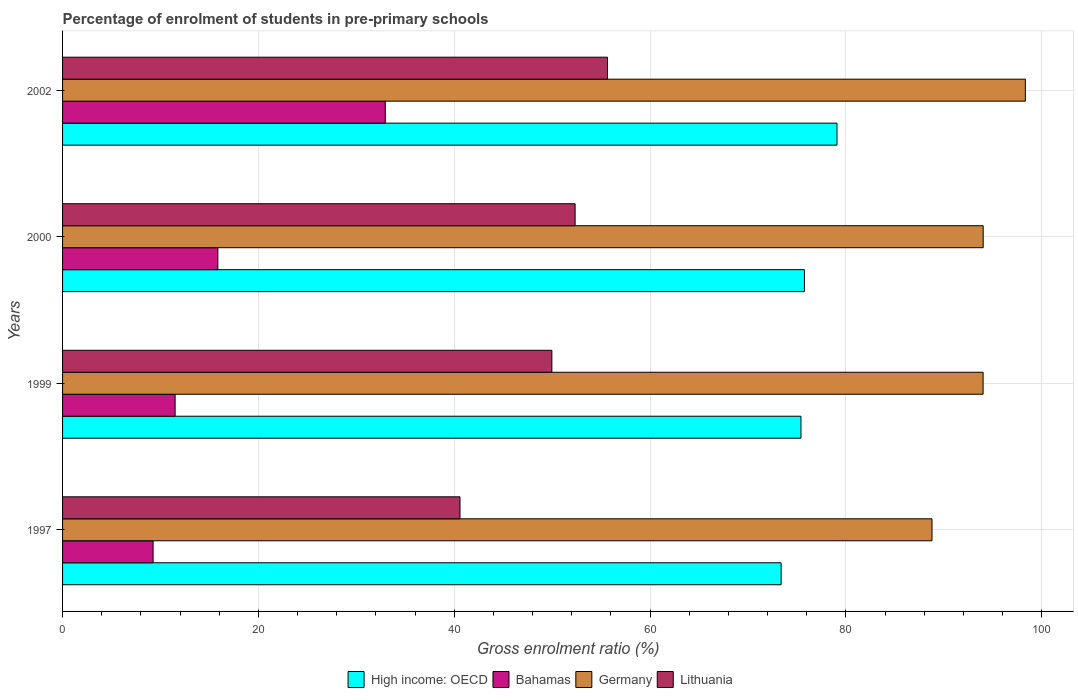Are the number of bars on each tick of the Y-axis equal?
Provide a short and direct response. Yes. How many bars are there on the 3rd tick from the bottom?
Your answer should be compact. 4. What is the percentage of students enrolled in pre-primary schools in Germany in 2000?
Your answer should be compact. 94.01. Across all years, what is the maximum percentage of students enrolled in pre-primary schools in Lithuania?
Offer a terse response. 55.65. Across all years, what is the minimum percentage of students enrolled in pre-primary schools in Lithuania?
Ensure brevity in your answer.  40.58. In which year was the percentage of students enrolled in pre-primary schools in Germany maximum?
Provide a succinct answer. 2002. What is the total percentage of students enrolled in pre-primary schools in High income: OECD in the graph?
Give a very brief answer. 303.62. What is the difference between the percentage of students enrolled in pre-primary schools in Bahamas in 1999 and that in 2002?
Make the answer very short. -21.46. What is the difference between the percentage of students enrolled in pre-primary schools in High income: OECD in 1997 and the percentage of students enrolled in pre-primary schools in Lithuania in 2002?
Your answer should be very brief. 17.73. What is the average percentage of students enrolled in pre-primary schools in Bahamas per year?
Ensure brevity in your answer.  17.39. In the year 1997, what is the difference between the percentage of students enrolled in pre-primary schools in Germany and percentage of students enrolled in pre-primary schools in Bahamas?
Your answer should be very brief. 79.54. In how many years, is the percentage of students enrolled in pre-primary schools in High income: OECD greater than 12 %?
Provide a short and direct response. 4. What is the ratio of the percentage of students enrolled in pre-primary schools in Bahamas in 1997 to that in 1999?
Keep it short and to the point. 0.8. Is the difference between the percentage of students enrolled in pre-primary schools in Germany in 1997 and 2000 greater than the difference between the percentage of students enrolled in pre-primary schools in Bahamas in 1997 and 2000?
Provide a succinct answer. Yes. What is the difference between the highest and the second highest percentage of students enrolled in pre-primary schools in Germany?
Your response must be concise. 4.31. What is the difference between the highest and the lowest percentage of students enrolled in pre-primary schools in Bahamas?
Ensure brevity in your answer.  23.71. In how many years, is the percentage of students enrolled in pre-primary schools in High income: OECD greater than the average percentage of students enrolled in pre-primary schools in High income: OECD taken over all years?
Offer a terse response. 1. Is the sum of the percentage of students enrolled in pre-primary schools in Bahamas in 1999 and 2000 greater than the maximum percentage of students enrolled in pre-primary schools in Lithuania across all years?
Your response must be concise. No. What does the 3rd bar from the top in 1997 represents?
Your answer should be very brief. Bahamas. What does the 1st bar from the bottom in 1999 represents?
Your answer should be compact. High income: OECD. Is it the case that in every year, the sum of the percentage of students enrolled in pre-primary schools in Germany and percentage of students enrolled in pre-primary schools in High income: OECD is greater than the percentage of students enrolled in pre-primary schools in Bahamas?
Offer a terse response. Yes. What is the difference between two consecutive major ticks on the X-axis?
Provide a short and direct response. 20. Are the values on the major ticks of X-axis written in scientific E-notation?
Provide a short and direct response. No. Does the graph contain grids?
Offer a terse response. Yes. Where does the legend appear in the graph?
Offer a terse response. Bottom center. How many legend labels are there?
Ensure brevity in your answer.  4. What is the title of the graph?
Provide a succinct answer. Percentage of enrolment of students in pre-primary schools. What is the label or title of the X-axis?
Ensure brevity in your answer.  Gross enrolment ratio (%). What is the label or title of the Y-axis?
Give a very brief answer. Years. What is the Gross enrolment ratio (%) of High income: OECD in 1997?
Offer a terse response. 73.38. What is the Gross enrolment ratio (%) in Bahamas in 1997?
Keep it short and to the point. 9.25. What is the Gross enrolment ratio (%) of Germany in 1997?
Give a very brief answer. 88.79. What is the Gross enrolment ratio (%) of Lithuania in 1997?
Make the answer very short. 40.58. What is the Gross enrolment ratio (%) of High income: OECD in 1999?
Offer a very short reply. 75.4. What is the Gross enrolment ratio (%) of Bahamas in 1999?
Make the answer very short. 11.49. What is the Gross enrolment ratio (%) in Germany in 1999?
Offer a terse response. 94. What is the Gross enrolment ratio (%) of Lithuania in 1999?
Your answer should be very brief. 49.97. What is the Gross enrolment ratio (%) of High income: OECD in 2000?
Offer a terse response. 75.76. What is the Gross enrolment ratio (%) in Bahamas in 2000?
Provide a succinct answer. 15.86. What is the Gross enrolment ratio (%) of Germany in 2000?
Your response must be concise. 94.01. What is the Gross enrolment ratio (%) in Lithuania in 2000?
Provide a succinct answer. 52.34. What is the Gross enrolment ratio (%) in High income: OECD in 2002?
Your answer should be very brief. 79.08. What is the Gross enrolment ratio (%) in Bahamas in 2002?
Give a very brief answer. 32.96. What is the Gross enrolment ratio (%) of Germany in 2002?
Offer a terse response. 98.32. What is the Gross enrolment ratio (%) in Lithuania in 2002?
Your answer should be compact. 55.65. Across all years, what is the maximum Gross enrolment ratio (%) in High income: OECD?
Ensure brevity in your answer.  79.08. Across all years, what is the maximum Gross enrolment ratio (%) of Bahamas?
Make the answer very short. 32.96. Across all years, what is the maximum Gross enrolment ratio (%) in Germany?
Keep it short and to the point. 98.32. Across all years, what is the maximum Gross enrolment ratio (%) of Lithuania?
Give a very brief answer. 55.65. Across all years, what is the minimum Gross enrolment ratio (%) of High income: OECD?
Provide a short and direct response. 73.38. Across all years, what is the minimum Gross enrolment ratio (%) of Bahamas?
Your response must be concise. 9.25. Across all years, what is the minimum Gross enrolment ratio (%) in Germany?
Give a very brief answer. 88.79. Across all years, what is the minimum Gross enrolment ratio (%) in Lithuania?
Provide a short and direct response. 40.58. What is the total Gross enrolment ratio (%) of High income: OECD in the graph?
Offer a very short reply. 303.62. What is the total Gross enrolment ratio (%) in Bahamas in the graph?
Keep it short and to the point. 69.55. What is the total Gross enrolment ratio (%) of Germany in the graph?
Make the answer very short. 375.12. What is the total Gross enrolment ratio (%) of Lithuania in the graph?
Offer a very short reply. 198.54. What is the difference between the Gross enrolment ratio (%) in High income: OECD in 1997 and that in 1999?
Ensure brevity in your answer.  -2.03. What is the difference between the Gross enrolment ratio (%) in Bahamas in 1997 and that in 1999?
Your answer should be very brief. -2.25. What is the difference between the Gross enrolment ratio (%) in Germany in 1997 and that in 1999?
Ensure brevity in your answer.  -5.22. What is the difference between the Gross enrolment ratio (%) of Lithuania in 1997 and that in 1999?
Your answer should be compact. -9.38. What is the difference between the Gross enrolment ratio (%) of High income: OECD in 1997 and that in 2000?
Provide a succinct answer. -2.38. What is the difference between the Gross enrolment ratio (%) of Bahamas in 1997 and that in 2000?
Provide a succinct answer. -6.61. What is the difference between the Gross enrolment ratio (%) of Germany in 1997 and that in 2000?
Make the answer very short. -5.23. What is the difference between the Gross enrolment ratio (%) in Lithuania in 1997 and that in 2000?
Offer a very short reply. -11.76. What is the difference between the Gross enrolment ratio (%) of High income: OECD in 1997 and that in 2002?
Make the answer very short. -5.71. What is the difference between the Gross enrolment ratio (%) of Bahamas in 1997 and that in 2002?
Your answer should be very brief. -23.71. What is the difference between the Gross enrolment ratio (%) in Germany in 1997 and that in 2002?
Offer a terse response. -9.53. What is the difference between the Gross enrolment ratio (%) in Lithuania in 1997 and that in 2002?
Your answer should be compact. -15.06. What is the difference between the Gross enrolment ratio (%) of High income: OECD in 1999 and that in 2000?
Provide a short and direct response. -0.35. What is the difference between the Gross enrolment ratio (%) in Bahamas in 1999 and that in 2000?
Offer a terse response. -4.37. What is the difference between the Gross enrolment ratio (%) in Germany in 1999 and that in 2000?
Your response must be concise. -0.01. What is the difference between the Gross enrolment ratio (%) of Lithuania in 1999 and that in 2000?
Your response must be concise. -2.37. What is the difference between the Gross enrolment ratio (%) of High income: OECD in 1999 and that in 2002?
Keep it short and to the point. -3.68. What is the difference between the Gross enrolment ratio (%) in Bahamas in 1999 and that in 2002?
Your answer should be very brief. -21.46. What is the difference between the Gross enrolment ratio (%) of Germany in 1999 and that in 2002?
Provide a succinct answer. -4.32. What is the difference between the Gross enrolment ratio (%) of Lithuania in 1999 and that in 2002?
Offer a terse response. -5.68. What is the difference between the Gross enrolment ratio (%) of High income: OECD in 2000 and that in 2002?
Your answer should be compact. -3.33. What is the difference between the Gross enrolment ratio (%) in Bahamas in 2000 and that in 2002?
Keep it short and to the point. -17.1. What is the difference between the Gross enrolment ratio (%) in Germany in 2000 and that in 2002?
Your answer should be very brief. -4.31. What is the difference between the Gross enrolment ratio (%) of Lithuania in 2000 and that in 2002?
Give a very brief answer. -3.31. What is the difference between the Gross enrolment ratio (%) of High income: OECD in 1997 and the Gross enrolment ratio (%) of Bahamas in 1999?
Offer a very short reply. 61.88. What is the difference between the Gross enrolment ratio (%) in High income: OECD in 1997 and the Gross enrolment ratio (%) in Germany in 1999?
Give a very brief answer. -20.63. What is the difference between the Gross enrolment ratio (%) of High income: OECD in 1997 and the Gross enrolment ratio (%) of Lithuania in 1999?
Make the answer very short. 23.41. What is the difference between the Gross enrolment ratio (%) in Bahamas in 1997 and the Gross enrolment ratio (%) in Germany in 1999?
Provide a short and direct response. -84.76. What is the difference between the Gross enrolment ratio (%) in Bahamas in 1997 and the Gross enrolment ratio (%) in Lithuania in 1999?
Offer a very short reply. -40.72. What is the difference between the Gross enrolment ratio (%) in Germany in 1997 and the Gross enrolment ratio (%) in Lithuania in 1999?
Keep it short and to the point. 38.82. What is the difference between the Gross enrolment ratio (%) in High income: OECD in 1997 and the Gross enrolment ratio (%) in Bahamas in 2000?
Your answer should be very brief. 57.52. What is the difference between the Gross enrolment ratio (%) in High income: OECD in 1997 and the Gross enrolment ratio (%) in Germany in 2000?
Ensure brevity in your answer.  -20.64. What is the difference between the Gross enrolment ratio (%) of High income: OECD in 1997 and the Gross enrolment ratio (%) of Lithuania in 2000?
Provide a short and direct response. 21.04. What is the difference between the Gross enrolment ratio (%) of Bahamas in 1997 and the Gross enrolment ratio (%) of Germany in 2000?
Make the answer very short. -84.77. What is the difference between the Gross enrolment ratio (%) of Bahamas in 1997 and the Gross enrolment ratio (%) of Lithuania in 2000?
Provide a short and direct response. -43.1. What is the difference between the Gross enrolment ratio (%) of Germany in 1997 and the Gross enrolment ratio (%) of Lithuania in 2000?
Your response must be concise. 36.45. What is the difference between the Gross enrolment ratio (%) in High income: OECD in 1997 and the Gross enrolment ratio (%) in Bahamas in 2002?
Make the answer very short. 40.42. What is the difference between the Gross enrolment ratio (%) in High income: OECD in 1997 and the Gross enrolment ratio (%) in Germany in 2002?
Offer a terse response. -24.94. What is the difference between the Gross enrolment ratio (%) of High income: OECD in 1997 and the Gross enrolment ratio (%) of Lithuania in 2002?
Offer a very short reply. 17.73. What is the difference between the Gross enrolment ratio (%) in Bahamas in 1997 and the Gross enrolment ratio (%) in Germany in 2002?
Ensure brevity in your answer.  -89.07. What is the difference between the Gross enrolment ratio (%) of Bahamas in 1997 and the Gross enrolment ratio (%) of Lithuania in 2002?
Your answer should be compact. -46.4. What is the difference between the Gross enrolment ratio (%) of Germany in 1997 and the Gross enrolment ratio (%) of Lithuania in 2002?
Give a very brief answer. 33.14. What is the difference between the Gross enrolment ratio (%) of High income: OECD in 1999 and the Gross enrolment ratio (%) of Bahamas in 2000?
Offer a very short reply. 59.54. What is the difference between the Gross enrolment ratio (%) in High income: OECD in 1999 and the Gross enrolment ratio (%) in Germany in 2000?
Keep it short and to the point. -18.61. What is the difference between the Gross enrolment ratio (%) in High income: OECD in 1999 and the Gross enrolment ratio (%) in Lithuania in 2000?
Your answer should be compact. 23.06. What is the difference between the Gross enrolment ratio (%) in Bahamas in 1999 and the Gross enrolment ratio (%) in Germany in 2000?
Keep it short and to the point. -82.52. What is the difference between the Gross enrolment ratio (%) in Bahamas in 1999 and the Gross enrolment ratio (%) in Lithuania in 2000?
Offer a very short reply. -40.85. What is the difference between the Gross enrolment ratio (%) of Germany in 1999 and the Gross enrolment ratio (%) of Lithuania in 2000?
Provide a short and direct response. 41.66. What is the difference between the Gross enrolment ratio (%) in High income: OECD in 1999 and the Gross enrolment ratio (%) in Bahamas in 2002?
Offer a very short reply. 42.45. What is the difference between the Gross enrolment ratio (%) of High income: OECD in 1999 and the Gross enrolment ratio (%) of Germany in 2002?
Your answer should be compact. -22.91. What is the difference between the Gross enrolment ratio (%) of High income: OECD in 1999 and the Gross enrolment ratio (%) of Lithuania in 2002?
Ensure brevity in your answer.  19.76. What is the difference between the Gross enrolment ratio (%) in Bahamas in 1999 and the Gross enrolment ratio (%) in Germany in 2002?
Keep it short and to the point. -86.83. What is the difference between the Gross enrolment ratio (%) of Bahamas in 1999 and the Gross enrolment ratio (%) of Lithuania in 2002?
Your response must be concise. -44.15. What is the difference between the Gross enrolment ratio (%) in Germany in 1999 and the Gross enrolment ratio (%) in Lithuania in 2002?
Ensure brevity in your answer.  38.36. What is the difference between the Gross enrolment ratio (%) of High income: OECD in 2000 and the Gross enrolment ratio (%) of Bahamas in 2002?
Your answer should be very brief. 42.8. What is the difference between the Gross enrolment ratio (%) in High income: OECD in 2000 and the Gross enrolment ratio (%) in Germany in 2002?
Offer a terse response. -22.56. What is the difference between the Gross enrolment ratio (%) of High income: OECD in 2000 and the Gross enrolment ratio (%) of Lithuania in 2002?
Your answer should be very brief. 20.11. What is the difference between the Gross enrolment ratio (%) of Bahamas in 2000 and the Gross enrolment ratio (%) of Germany in 2002?
Make the answer very short. -82.46. What is the difference between the Gross enrolment ratio (%) of Bahamas in 2000 and the Gross enrolment ratio (%) of Lithuania in 2002?
Provide a succinct answer. -39.79. What is the difference between the Gross enrolment ratio (%) of Germany in 2000 and the Gross enrolment ratio (%) of Lithuania in 2002?
Offer a very short reply. 38.37. What is the average Gross enrolment ratio (%) in High income: OECD per year?
Provide a succinct answer. 75.91. What is the average Gross enrolment ratio (%) of Bahamas per year?
Provide a succinct answer. 17.39. What is the average Gross enrolment ratio (%) of Germany per year?
Provide a short and direct response. 93.78. What is the average Gross enrolment ratio (%) of Lithuania per year?
Your answer should be very brief. 49.63. In the year 1997, what is the difference between the Gross enrolment ratio (%) of High income: OECD and Gross enrolment ratio (%) of Bahamas?
Ensure brevity in your answer.  64.13. In the year 1997, what is the difference between the Gross enrolment ratio (%) in High income: OECD and Gross enrolment ratio (%) in Germany?
Provide a succinct answer. -15.41. In the year 1997, what is the difference between the Gross enrolment ratio (%) in High income: OECD and Gross enrolment ratio (%) in Lithuania?
Offer a terse response. 32.79. In the year 1997, what is the difference between the Gross enrolment ratio (%) of Bahamas and Gross enrolment ratio (%) of Germany?
Offer a very short reply. -79.54. In the year 1997, what is the difference between the Gross enrolment ratio (%) of Bahamas and Gross enrolment ratio (%) of Lithuania?
Give a very brief answer. -31.34. In the year 1997, what is the difference between the Gross enrolment ratio (%) of Germany and Gross enrolment ratio (%) of Lithuania?
Your answer should be compact. 48.2. In the year 1999, what is the difference between the Gross enrolment ratio (%) in High income: OECD and Gross enrolment ratio (%) in Bahamas?
Your response must be concise. 63.91. In the year 1999, what is the difference between the Gross enrolment ratio (%) of High income: OECD and Gross enrolment ratio (%) of Germany?
Provide a succinct answer. -18.6. In the year 1999, what is the difference between the Gross enrolment ratio (%) in High income: OECD and Gross enrolment ratio (%) in Lithuania?
Keep it short and to the point. 25.44. In the year 1999, what is the difference between the Gross enrolment ratio (%) of Bahamas and Gross enrolment ratio (%) of Germany?
Your response must be concise. -82.51. In the year 1999, what is the difference between the Gross enrolment ratio (%) in Bahamas and Gross enrolment ratio (%) in Lithuania?
Provide a short and direct response. -38.47. In the year 1999, what is the difference between the Gross enrolment ratio (%) of Germany and Gross enrolment ratio (%) of Lithuania?
Offer a very short reply. 44.04. In the year 2000, what is the difference between the Gross enrolment ratio (%) in High income: OECD and Gross enrolment ratio (%) in Bahamas?
Give a very brief answer. 59.9. In the year 2000, what is the difference between the Gross enrolment ratio (%) of High income: OECD and Gross enrolment ratio (%) of Germany?
Keep it short and to the point. -18.25. In the year 2000, what is the difference between the Gross enrolment ratio (%) in High income: OECD and Gross enrolment ratio (%) in Lithuania?
Make the answer very short. 23.42. In the year 2000, what is the difference between the Gross enrolment ratio (%) of Bahamas and Gross enrolment ratio (%) of Germany?
Make the answer very short. -78.15. In the year 2000, what is the difference between the Gross enrolment ratio (%) of Bahamas and Gross enrolment ratio (%) of Lithuania?
Give a very brief answer. -36.48. In the year 2000, what is the difference between the Gross enrolment ratio (%) of Germany and Gross enrolment ratio (%) of Lithuania?
Provide a succinct answer. 41.67. In the year 2002, what is the difference between the Gross enrolment ratio (%) in High income: OECD and Gross enrolment ratio (%) in Bahamas?
Give a very brief answer. 46.13. In the year 2002, what is the difference between the Gross enrolment ratio (%) of High income: OECD and Gross enrolment ratio (%) of Germany?
Your answer should be very brief. -19.23. In the year 2002, what is the difference between the Gross enrolment ratio (%) of High income: OECD and Gross enrolment ratio (%) of Lithuania?
Ensure brevity in your answer.  23.44. In the year 2002, what is the difference between the Gross enrolment ratio (%) in Bahamas and Gross enrolment ratio (%) in Germany?
Your answer should be very brief. -65.36. In the year 2002, what is the difference between the Gross enrolment ratio (%) of Bahamas and Gross enrolment ratio (%) of Lithuania?
Your answer should be very brief. -22.69. In the year 2002, what is the difference between the Gross enrolment ratio (%) in Germany and Gross enrolment ratio (%) in Lithuania?
Make the answer very short. 42.67. What is the ratio of the Gross enrolment ratio (%) in High income: OECD in 1997 to that in 1999?
Offer a very short reply. 0.97. What is the ratio of the Gross enrolment ratio (%) of Bahamas in 1997 to that in 1999?
Your answer should be very brief. 0.8. What is the ratio of the Gross enrolment ratio (%) of Germany in 1997 to that in 1999?
Offer a very short reply. 0.94. What is the ratio of the Gross enrolment ratio (%) in Lithuania in 1997 to that in 1999?
Your answer should be compact. 0.81. What is the ratio of the Gross enrolment ratio (%) in High income: OECD in 1997 to that in 2000?
Provide a short and direct response. 0.97. What is the ratio of the Gross enrolment ratio (%) of Bahamas in 1997 to that in 2000?
Make the answer very short. 0.58. What is the ratio of the Gross enrolment ratio (%) in Lithuania in 1997 to that in 2000?
Make the answer very short. 0.78. What is the ratio of the Gross enrolment ratio (%) of High income: OECD in 1997 to that in 2002?
Provide a short and direct response. 0.93. What is the ratio of the Gross enrolment ratio (%) of Bahamas in 1997 to that in 2002?
Make the answer very short. 0.28. What is the ratio of the Gross enrolment ratio (%) in Germany in 1997 to that in 2002?
Your answer should be very brief. 0.9. What is the ratio of the Gross enrolment ratio (%) of Lithuania in 1997 to that in 2002?
Your answer should be compact. 0.73. What is the ratio of the Gross enrolment ratio (%) in High income: OECD in 1999 to that in 2000?
Your answer should be very brief. 1. What is the ratio of the Gross enrolment ratio (%) in Bahamas in 1999 to that in 2000?
Provide a short and direct response. 0.72. What is the ratio of the Gross enrolment ratio (%) of Germany in 1999 to that in 2000?
Provide a succinct answer. 1. What is the ratio of the Gross enrolment ratio (%) in Lithuania in 1999 to that in 2000?
Your answer should be very brief. 0.95. What is the ratio of the Gross enrolment ratio (%) in High income: OECD in 1999 to that in 2002?
Provide a short and direct response. 0.95. What is the ratio of the Gross enrolment ratio (%) of Bahamas in 1999 to that in 2002?
Your answer should be very brief. 0.35. What is the ratio of the Gross enrolment ratio (%) in Germany in 1999 to that in 2002?
Give a very brief answer. 0.96. What is the ratio of the Gross enrolment ratio (%) in Lithuania in 1999 to that in 2002?
Your answer should be very brief. 0.9. What is the ratio of the Gross enrolment ratio (%) of High income: OECD in 2000 to that in 2002?
Your answer should be very brief. 0.96. What is the ratio of the Gross enrolment ratio (%) in Bahamas in 2000 to that in 2002?
Provide a short and direct response. 0.48. What is the ratio of the Gross enrolment ratio (%) in Germany in 2000 to that in 2002?
Keep it short and to the point. 0.96. What is the ratio of the Gross enrolment ratio (%) of Lithuania in 2000 to that in 2002?
Ensure brevity in your answer.  0.94. What is the difference between the highest and the second highest Gross enrolment ratio (%) of High income: OECD?
Give a very brief answer. 3.33. What is the difference between the highest and the second highest Gross enrolment ratio (%) in Bahamas?
Make the answer very short. 17.1. What is the difference between the highest and the second highest Gross enrolment ratio (%) in Germany?
Your response must be concise. 4.31. What is the difference between the highest and the second highest Gross enrolment ratio (%) in Lithuania?
Provide a succinct answer. 3.31. What is the difference between the highest and the lowest Gross enrolment ratio (%) in High income: OECD?
Offer a terse response. 5.71. What is the difference between the highest and the lowest Gross enrolment ratio (%) in Bahamas?
Make the answer very short. 23.71. What is the difference between the highest and the lowest Gross enrolment ratio (%) of Germany?
Provide a short and direct response. 9.53. What is the difference between the highest and the lowest Gross enrolment ratio (%) of Lithuania?
Your answer should be compact. 15.06. 